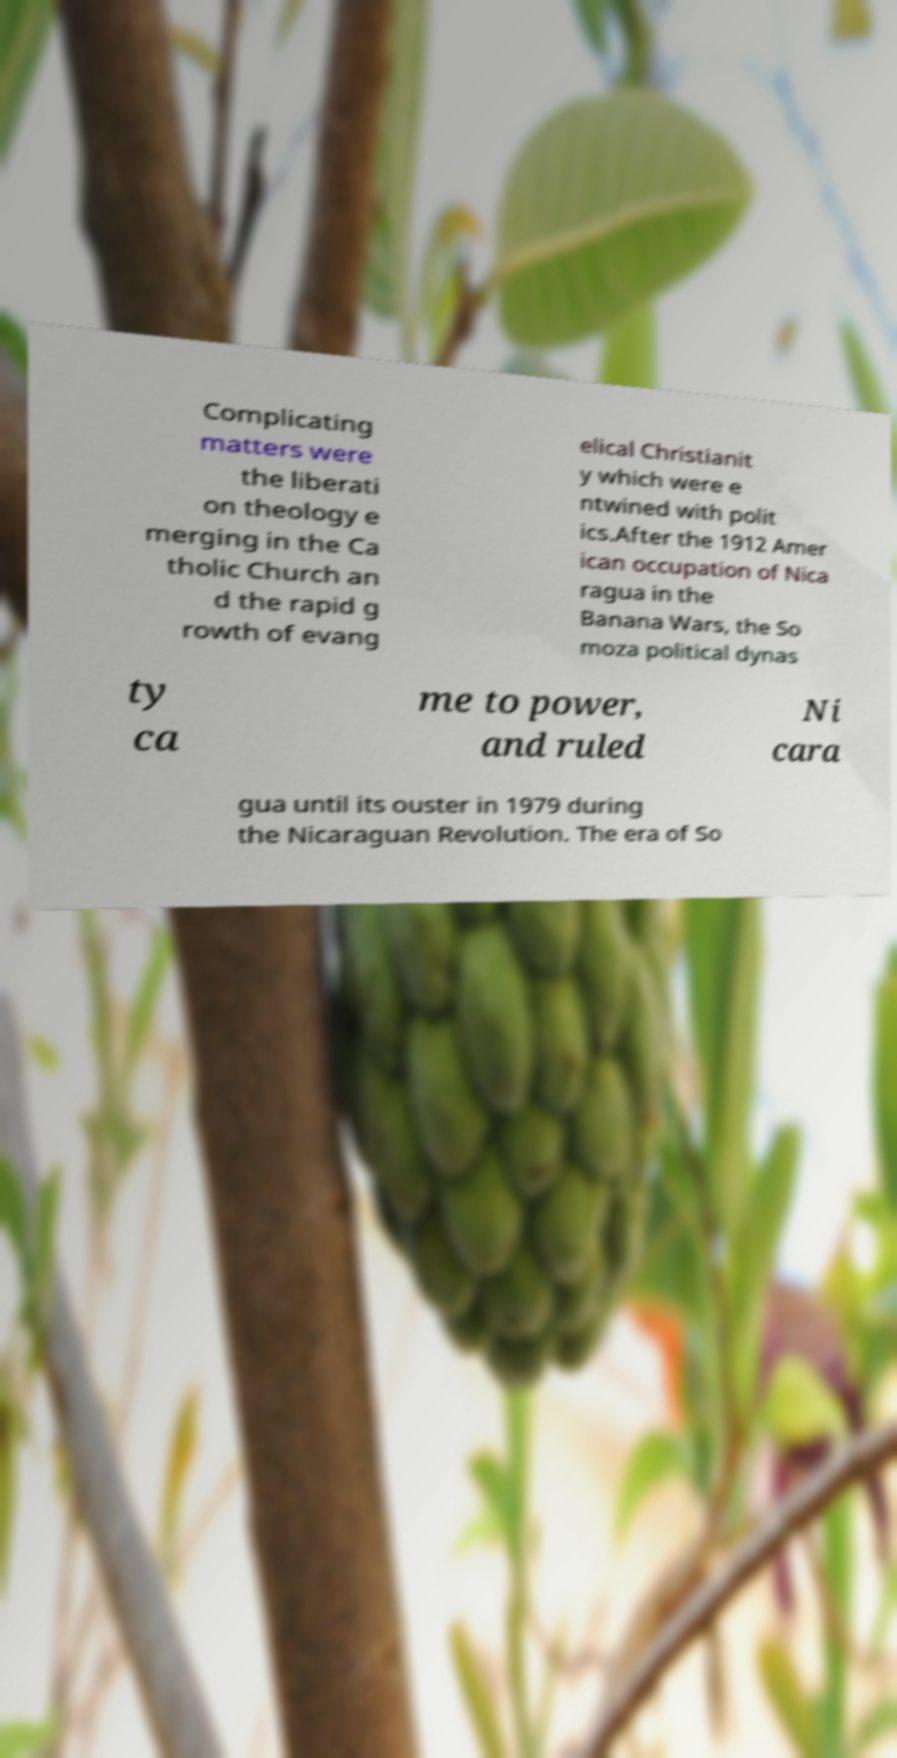Could you assist in decoding the text presented in this image and type it out clearly? Complicating matters were the liberati on theology e merging in the Ca tholic Church an d the rapid g rowth of evang elical Christianit y which were e ntwined with polit ics.After the 1912 Amer ican occupation of Nica ragua in the Banana Wars, the So moza political dynas ty ca me to power, and ruled Ni cara gua until its ouster in 1979 during the Nicaraguan Revolution. The era of So 